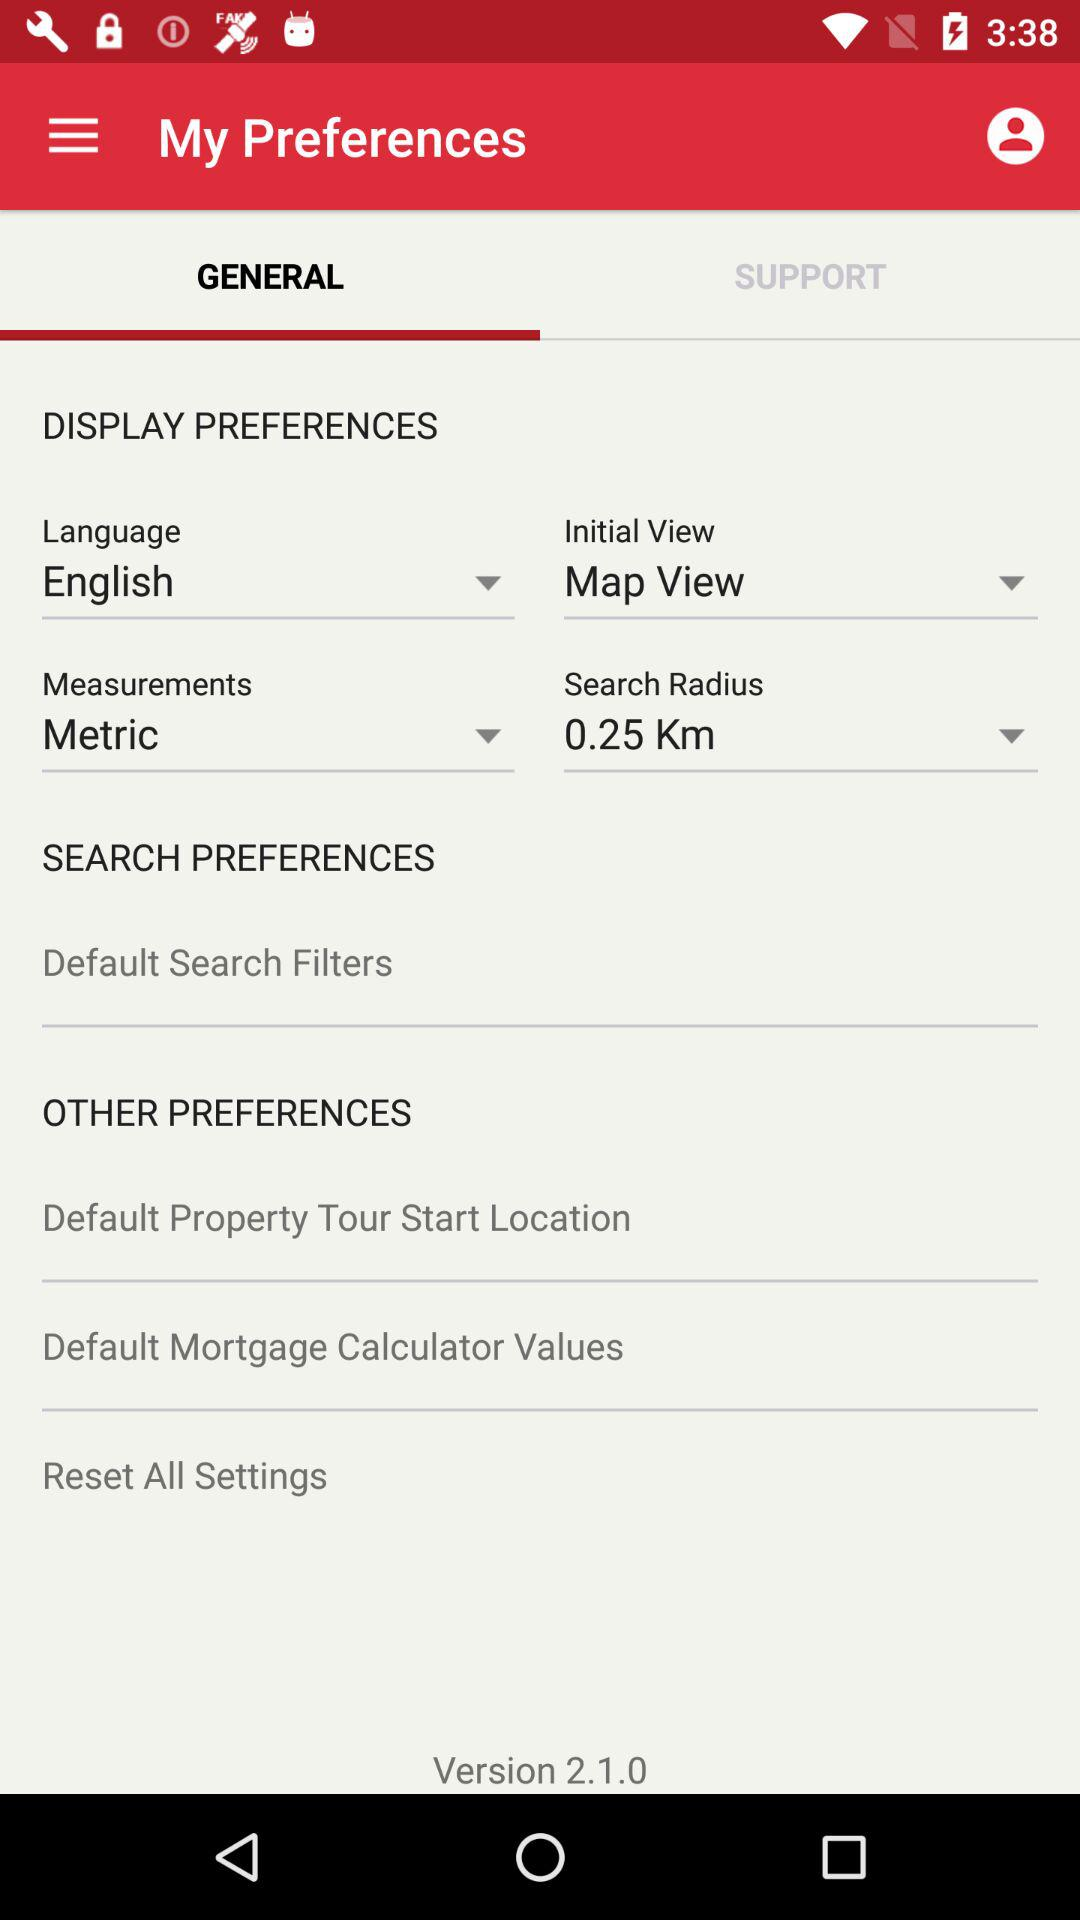What language option is selected? The selected option is "English". 